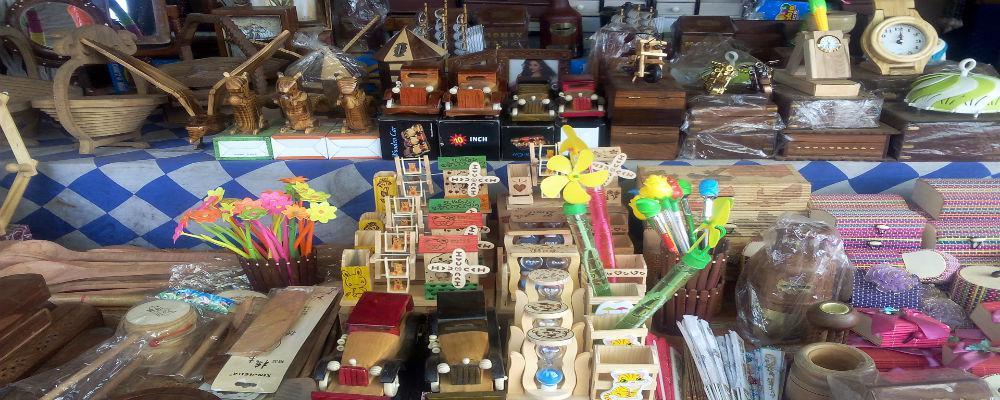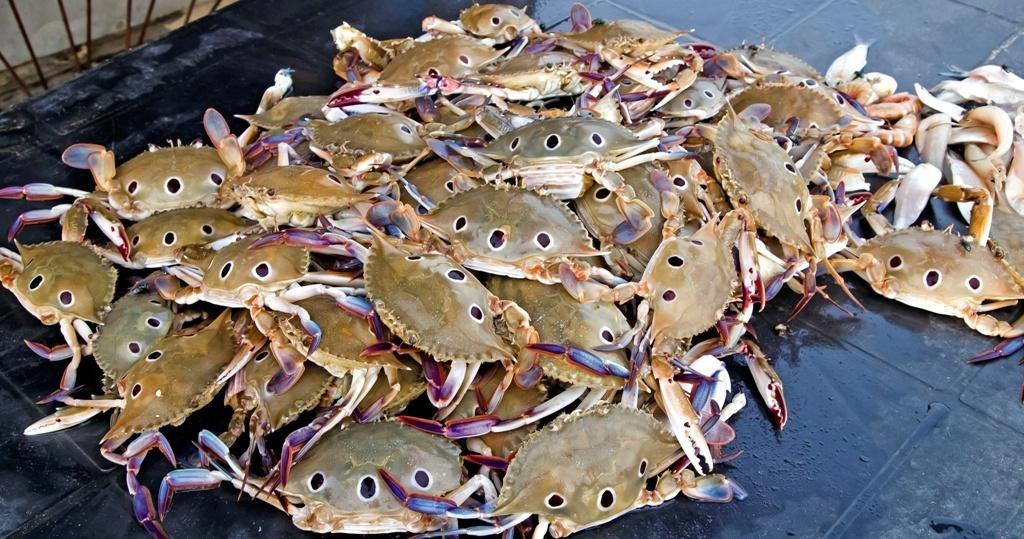The first image is the image on the left, the second image is the image on the right. Examine the images to the left and right. Is the description "There are at least three crabs in the image pair." accurate? Answer yes or no. Yes. 